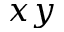<formula> <loc_0><loc_0><loc_500><loc_500>x y</formula> 